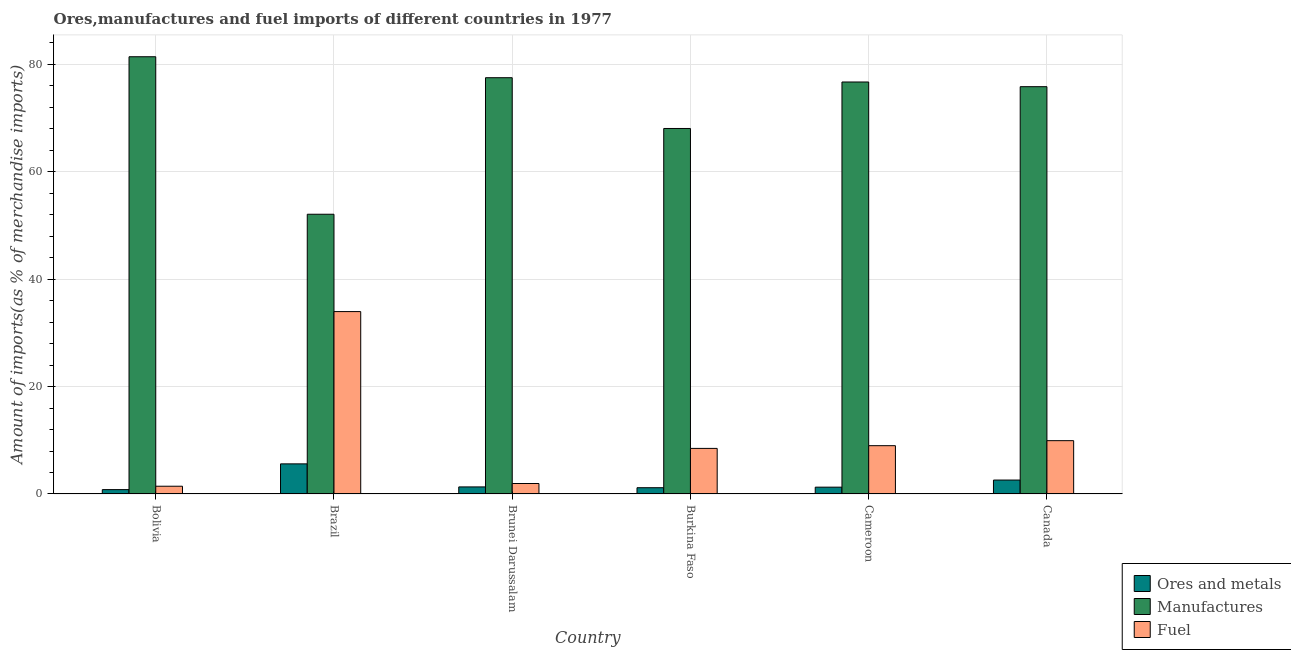Are the number of bars per tick equal to the number of legend labels?
Provide a succinct answer. Yes. Are the number of bars on each tick of the X-axis equal?
Provide a short and direct response. Yes. How many bars are there on the 1st tick from the right?
Offer a very short reply. 3. What is the label of the 3rd group of bars from the left?
Make the answer very short. Brunei Darussalam. In how many cases, is the number of bars for a given country not equal to the number of legend labels?
Offer a terse response. 0. What is the percentage of fuel imports in Canada?
Give a very brief answer. 9.93. Across all countries, what is the maximum percentage of manufactures imports?
Your response must be concise. 81.43. Across all countries, what is the minimum percentage of manufactures imports?
Offer a very short reply. 52.09. In which country was the percentage of manufactures imports maximum?
Ensure brevity in your answer.  Bolivia. In which country was the percentage of manufactures imports minimum?
Offer a terse response. Brazil. What is the total percentage of manufactures imports in the graph?
Keep it short and to the point. 431.69. What is the difference between the percentage of ores and metals imports in Brazil and that in Burkina Faso?
Offer a very short reply. 4.44. What is the difference between the percentage of fuel imports in Bolivia and the percentage of ores and metals imports in Brazil?
Provide a short and direct response. -4.16. What is the average percentage of ores and metals imports per country?
Give a very brief answer. 2.13. What is the difference between the percentage of fuel imports and percentage of ores and metals imports in Cameroon?
Provide a short and direct response. 7.73. In how many countries, is the percentage of manufactures imports greater than 24 %?
Offer a terse response. 6. What is the ratio of the percentage of fuel imports in Bolivia to that in Canada?
Offer a terse response. 0.15. What is the difference between the highest and the second highest percentage of manufactures imports?
Make the answer very short. 3.91. What is the difference between the highest and the lowest percentage of manufactures imports?
Offer a very short reply. 29.33. In how many countries, is the percentage of manufactures imports greater than the average percentage of manufactures imports taken over all countries?
Your response must be concise. 4. Is the sum of the percentage of fuel imports in Brunei Darussalam and Cameroon greater than the maximum percentage of ores and metals imports across all countries?
Your answer should be compact. Yes. What does the 1st bar from the left in Cameroon represents?
Ensure brevity in your answer.  Ores and metals. What does the 1st bar from the right in Cameroon represents?
Keep it short and to the point. Fuel. Are all the bars in the graph horizontal?
Your answer should be compact. No. How many countries are there in the graph?
Offer a terse response. 6. Are the values on the major ticks of Y-axis written in scientific E-notation?
Offer a terse response. No. How many legend labels are there?
Give a very brief answer. 3. How are the legend labels stacked?
Offer a very short reply. Vertical. What is the title of the graph?
Make the answer very short. Ores,manufactures and fuel imports of different countries in 1977. What is the label or title of the X-axis?
Provide a succinct answer. Country. What is the label or title of the Y-axis?
Your answer should be very brief. Amount of imports(as % of merchandise imports). What is the Amount of imports(as % of merchandise imports) of Ores and metals in Bolivia?
Your answer should be very brief. 0.81. What is the Amount of imports(as % of merchandise imports) in Manufactures in Bolivia?
Your answer should be very brief. 81.43. What is the Amount of imports(as % of merchandise imports) in Fuel in Bolivia?
Offer a very short reply. 1.44. What is the Amount of imports(as % of merchandise imports) in Ores and metals in Brazil?
Your answer should be very brief. 5.61. What is the Amount of imports(as % of merchandise imports) in Manufactures in Brazil?
Offer a very short reply. 52.09. What is the Amount of imports(as % of merchandise imports) in Fuel in Brazil?
Your answer should be very brief. 33.97. What is the Amount of imports(as % of merchandise imports) in Ores and metals in Brunei Darussalam?
Your response must be concise. 1.31. What is the Amount of imports(as % of merchandise imports) in Manufactures in Brunei Darussalam?
Your answer should be very brief. 77.52. What is the Amount of imports(as % of merchandise imports) in Fuel in Brunei Darussalam?
Your response must be concise. 1.95. What is the Amount of imports(as % of merchandise imports) of Ores and metals in Burkina Faso?
Your answer should be very brief. 1.16. What is the Amount of imports(as % of merchandise imports) in Manufactures in Burkina Faso?
Your answer should be very brief. 68.07. What is the Amount of imports(as % of merchandise imports) of Fuel in Burkina Faso?
Your response must be concise. 8.49. What is the Amount of imports(as % of merchandise imports) of Ores and metals in Cameroon?
Make the answer very short. 1.27. What is the Amount of imports(as % of merchandise imports) in Manufactures in Cameroon?
Give a very brief answer. 76.72. What is the Amount of imports(as % of merchandise imports) in Fuel in Cameroon?
Ensure brevity in your answer.  8.99. What is the Amount of imports(as % of merchandise imports) of Ores and metals in Canada?
Provide a short and direct response. 2.59. What is the Amount of imports(as % of merchandise imports) in Manufactures in Canada?
Your answer should be very brief. 75.85. What is the Amount of imports(as % of merchandise imports) in Fuel in Canada?
Ensure brevity in your answer.  9.93. Across all countries, what is the maximum Amount of imports(as % of merchandise imports) in Ores and metals?
Provide a short and direct response. 5.61. Across all countries, what is the maximum Amount of imports(as % of merchandise imports) of Manufactures?
Provide a succinct answer. 81.43. Across all countries, what is the maximum Amount of imports(as % of merchandise imports) in Fuel?
Keep it short and to the point. 33.97. Across all countries, what is the minimum Amount of imports(as % of merchandise imports) of Ores and metals?
Offer a very short reply. 0.81. Across all countries, what is the minimum Amount of imports(as % of merchandise imports) in Manufactures?
Provide a succinct answer. 52.09. Across all countries, what is the minimum Amount of imports(as % of merchandise imports) of Fuel?
Offer a terse response. 1.44. What is the total Amount of imports(as % of merchandise imports) of Ores and metals in the graph?
Make the answer very short. 12.75. What is the total Amount of imports(as % of merchandise imports) in Manufactures in the graph?
Make the answer very short. 431.69. What is the total Amount of imports(as % of merchandise imports) in Fuel in the graph?
Provide a short and direct response. 64.77. What is the difference between the Amount of imports(as % of merchandise imports) of Ores and metals in Bolivia and that in Brazil?
Offer a very short reply. -4.79. What is the difference between the Amount of imports(as % of merchandise imports) of Manufactures in Bolivia and that in Brazil?
Your answer should be very brief. 29.33. What is the difference between the Amount of imports(as % of merchandise imports) of Fuel in Bolivia and that in Brazil?
Your response must be concise. -32.52. What is the difference between the Amount of imports(as % of merchandise imports) in Ores and metals in Bolivia and that in Brunei Darussalam?
Make the answer very short. -0.5. What is the difference between the Amount of imports(as % of merchandise imports) of Manufactures in Bolivia and that in Brunei Darussalam?
Provide a succinct answer. 3.91. What is the difference between the Amount of imports(as % of merchandise imports) of Fuel in Bolivia and that in Brunei Darussalam?
Offer a terse response. -0.51. What is the difference between the Amount of imports(as % of merchandise imports) of Ores and metals in Bolivia and that in Burkina Faso?
Your answer should be very brief. -0.35. What is the difference between the Amount of imports(as % of merchandise imports) in Manufactures in Bolivia and that in Burkina Faso?
Your answer should be compact. 13.36. What is the difference between the Amount of imports(as % of merchandise imports) of Fuel in Bolivia and that in Burkina Faso?
Provide a short and direct response. -7.04. What is the difference between the Amount of imports(as % of merchandise imports) in Ores and metals in Bolivia and that in Cameroon?
Make the answer very short. -0.45. What is the difference between the Amount of imports(as % of merchandise imports) in Manufactures in Bolivia and that in Cameroon?
Give a very brief answer. 4.7. What is the difference between the Amount of imports(as % of merchandise imports) of Fuel in Bolivia and that in Cameroon?
Provide a succinct answer. -7.55. What is the difference between the Amount of imports(as % of merchandise imports) of Ores and metals in Bolivia and that in Canada?
Offer a very short reply. -1.78. What is the difference between the Amount of imports(as % of merchandise imports) of Manufactures in Bolivia and that in Canada?
Offer a terse response. 5.58. What is the difference between the Amount of imports(as % of merchandise imports) of Fuel in Bolivia and that in Canada?
Make the answer very short. -8.49. What is the difference between the Amount of imports(as % of merchandise imports) in Ores and metals in Brazil and that in Brunei Darussalam?
Provide a succinct answer. 4.29. What is the difference between the Amount of imports(as % of merchandise imports) of Manufactures in Brazil and that in Brunei Darussalam?
Keep it short and to the point. -25.43. What is the difference between the Amount of imports(as % of merchandise imports) in Fuel in Brazil and that in Brunei Darussalam?
Offer a terse response. 32.02. What is the difference between the Amount of imports(as % of merchandise imports) of Ores and metals in Brazil and that in Burkina Faso?
Keep it short and to the point. 4.44. What is the difference between the Amount of imports(as % of merchandise imports) in Manufactures in Brazil and that in Burkina Faso?
Ensure brevity in your answer.  -15.97. What is the difference between the Amount of imports(as % of merchandise imports) in Fuel in Brazil and that in Burkina Faso?
Offer a very short reply. 25.48. What is the difference between the Amount of imports(as % of merchandise imports) of Ores and metals in Brazil and that in Cameroon?
Give a very brief answer. 4.34. What is the difference between the Amount of imports(as % of merchandise imports) in Manufactures in Brazil and that in Cameroon?
Your answer should be compact. -24.63. What is the difference between the Amount of imports(as % of merchandise imports) of Fuel in Brazil and that in Cameroon?
Your answer should be very brief. 24.97. What is the difference between the Amount of imports(as % of merchandise imports) in Ores and metals in Brazil and that in Canada?
Offer a very short reply. 3.01. What is the difference between the Amount of imports(as % of merchandise imports) in Manufactures in Brazil and that in Canada?
Provide a short and direct response. -23.76. What is the difference between the Amount of imports(as % of merchandise imports) in Fuel in Brazil and that in Canada?
Provide a succinct answer. 24.04. What is the difference between the Amount of imports(as % of merchandise imports) in Ores and metals in Brunei Darussalam and that in Burkina Faso?
Keep it short and to the point. 0.15. What is the difference between the Amount of imports(as % of merchandise imports) of Manufactures in Brunei Darussalam and that in Burkina Faso?
Offer a very short reply. 9.45. What is the difference between the Amount of imports(as % of merchandise imports) of Fuel in Brunei Darussalam and that in Burkina Faso?
Make the answer very short. -6.54. What is the difference between the Amount of imports(as % of merchandise imports) of Ores and metals in Brunei Darussalam and that in Cameroon?
Ensure brevity in your answer.  0.05. What is the difference between the Amount of imports(as % of merchandise imports) of Manufactures in Brunei Darussalam and that in Cameroon?
Offer a terse response. 0.8. What is the difference between the Amount of imports(as % of merchandise imports) of Fuel in Brunei Darussalam and that in Cameroon?
Your answer should be compact. -7.04. What is the difference between the Amount of imports(as % of merchandise imports) of Ores and metals in Brunei Darussalam and that in Canada?
Give a very brief answer. -1.28. What is the difference between the Amount of imports(as % of merchandise imports) in Manufactures in Brunei Darussalam and that in Canada?
Offer a very short reply. 1.67. What is the difference between the Amount of imports(as % of merchandise imports) of Fuel in Brunei Darussalam and that in Canada?
Offer a very short reply. -7.98. What is the difference between the Amount of imports(as % of merchandise imports) of Ores and metals in Burkina Faso and that in Cameroon?
Your response must be concise. -0.1. What is the difference between the Amount of imports(as % of merchandise imports) in Manufactures in Burkina Faso and that in Cameroon?
Your answer should be compact. -8.66. What is the difference between the Amount of imports(as % of merchandise imports) in Fuel in Burkina Faso and that in Cameroon?
Give a very brief answer. -0.51. What is the difference between the Amount of imports(as % of merchandise imports) of Ores and metals in Burkina Faso and that in Canada?
Your answer should be very brief. -1.43. What is the difference between the Amount of imports(as % of merchandise imports) in Manufactures in Burkina Faso and that in Canada?
Ensure brevity in your answer.  -7.78. What is the difference between the Amount of imports(as % of merchandise imports) in Fuel in Burkina Faso and that in Canada?
Make the answer very short. -1.44. What is the difference between the Amount of imports(as % of merchandise imports) of Ores and metals in Cameroon and that in Canada?
Ensure brevity in your answer.  -1.32. What is the difference between the Amount of imports(as % of merchandise imports) in Manufactures in Cameroon and that in Canada?
Your response must be concise. 0.87. What is the difference between the Amount of imports(as % of merchandise imports) of Fuel in Cameroon and that in Canada?
Your response must be concise. -0.94. What is the difference between the Amount of imports(as % of merchandise imports) in Ores and metals in Bolivia and the Amount of imports(as % of merchandise imports) in Manufactures in Brazil?
Keep it short and to the point. -51.28. What is the difference between the Amount of imports(as % of merchandise imports) in Ores and metals in Bolivia and the Amount of imports(as % of merchandise imports) in Fuel in Brazil?
Your answer should be very brief. -33.15. What is the difference between the Amount of imports(as % of merchandise imports) in Manufactures in Bolivia and the Amount of imports(as % of merchandise imports) in Fuel in Brazil?
Offer a very short reply. 47.46. What is the difference between the Amount of imports(as % of merchandise imports) in Ores and metals in Bolivia and the Amount of imports(as % of merchandise imports) in Manufactures in Brunei Darussalam?
Give a very brief answer. -76.71. What is the difference between the Amount of imports(as % of merchandise imports) in Ores and metals in Bolivia and the Amount of imports(as % of merchandise imports) in Fuel in Brunei Darussalam?
Your response must be concise. -1.14. What is the difference between the Amount of imports(as % of merchandise imports) in Manufactures in Bolivia and the Amount of imports(as % of merchandise imports) in Fuel in Brunei Darussalam?
Provide a short and direct response. 79.48. What is the difference between the Amount of imports(as % of merchandise imports) in Ores and metals in Bolivia and the Amount of imports(as % of merchandise imports) in Manufactures in Burkina Faso?
Keep it short and to the point. -67.26. What is the difference between the Amount of imports(as % of merchandise imports) in Ores and metals in Bolivia and the Amount of imports(as % of merchandise imports) in Fuel in Burkina Faso?
Your response must be concise. -7.67. What is the difference between the Amount of imports(as % of merchandise imports) in Manufactures in Bolivia and the Amount of imports(as % of merchandise imports) in Fuel in Burkina Faso?
Provide a succinct answer. 72.94. What is the difference between the Amount of imports(as % of merchandise imports) in Ores and metals in Bolivia and the Amount of imports(as % of merchandise imports) in Manufactures in Cameroon?
Keep it short and to the point. -75.91. What is the difference between the Amount of imports(as % of merchandise imports) of Ores and metals in Bolivia and the Amount of imports(as % of merchandise imports) of Fuel in Cameroon?
Provide a succinct answer. -8.18. What is the difference between the Amount of imports(as % of merchandise imports) of Manufactures in Bolivia and the Amount of imports(as % of merchandise imports) of Fuel in Cameroon?
Your answer should be very brief. 72.44. What is the difference between the Amount of imports(as % of merchandise imports) of Ores and metals in Bolivia and the Amount of imports(as % of merchandise imports) of Manufactures in Canada?
Keep it short and to the point. -75.04. What is the difference between the Amount of imports(as % of merchandise imports) of Ores and metals in Bolivia and the Amount of imports(as % of merchandise imports) of Fuel in Canada?
Give a very brief answer. -9.12. What is the difference between the Amount of imports(as % of merchandise imports) of Manufactures in Bolivia and the Amount of imports(as % of merchandise imports) of Fuel in Canada?
Offer a terse response. 71.5. What is the difference between the Amount of imports(as % of merchandise imports) in Ores and metals in Brazil and the Amount of imports(as % of merchandise imports) in Manufactures in Brunei Darussalam?
Your response must be concise. -71.92. What is the difference between the Amount of imports(as % of merchandise imports) of Ores and metals in Brazil and the Amount of imports(as % of merchandise imports) of Fuel in Brunei Darussalam?
Provide a short and direct response. 3.66. What is the difference between the Amount of imports(as % of merchandise imports) of Manufactures in Brazil and the Amount of imports(as % of merchandise imports) of Fuel in Brunei Darussalam?
Your answer should be very brief. 50.15. What is the difference between the Amount of imports(as % of merchandise imports) in Ores and metals in Brazil and the Amount of imports(as % of merchandise imports) in Manufactures in Burkina Faso?
Your response must be concise. -62.46. What is the difference between the Amount of imports(as % of merchandise imports) in Ores and metals in Brazil and the Amount of imports(as % of merchandise imports) in Fuel in Burkina Faso?
Offer a very short reply. -2.88. What is the difference between the Amount of imports(as % of merchandise imports) of Manufactures in Brazil and the Amount of imports(as % of merchandise imports) of Fuel in Burkina Faso?
Your answer should be compact. 43.61. What is the difference between the Amount of imports(as % of merchandise imports) of Ores and metals in Brazil and the Amount of imports(as % of merchandise imports) of Manufactures in Cameroon?
Give a very brief answer. -71.12. What is the difference between the Amount of imports(as % of merchandise imports) of Ores and metals in Brazil and the Amount of imports(as % of merchandise imports) of Fuel in Cameroon?
Ensure brevity in your answer.  -3.39. What is the difference between the Amount of imports(as % of merchandise imports) in Manufactures in Brazil and the Amount of imports(as % of merchandise imports) in Fuel in Cameroon?
Provide a succinct answer. 43.1. What is the difference between the Amount of imports(as % of merchandise imports) of Ores and metals in Brazil and the Amount of imports(as % of merchandise imports) of Manufactures in Canada?
Offer a very short reply. -70.25. What is the difference between the Amount of imports(as % of merchandise imports) of Ores and metals in Brazil and the Amount of imports(as % of merchandise imports) of Fuel in Canada?
Provide a short and direct response. -4.32. What is the difference between the Amount of imports(as % of merchandise imports) of Manufactures in Brazil and the Amount of imports(as % of merchandise imports) of Fuel in Canada?
Offer a terse response. 42.17. What is the difference between the Amount of imports(as % of merchandise imports) of Ores and metals in Brunei Darussalam and the Amount of imports(as % of merchandise imports) of Manufactures in Burkina Faso?
Give a very brief answer. -66.75. What is the difference between the Amount of imports(as % of merchandise imports) of Ores and metals in Brunei Darussalam and the Amount of imports(as % of merchandise imports) of Fuel in Burkina Faso?
Give a very brief answer. -7.17. What is the difference between the Amount of imports(as % of merchandise imports) in Manufactures in Brunei Darussalam and the Amount of imports(as % of merchandise imports) in Fuel in Burkina Faso?
Make the answer very short. 69.04. What is the difference between the Amount of imports(as % of merchandise imports) in Ores and metals in Brunei Darussalam and the Amount of imports(as % of merchandise imports) in Manufactures in Cameroon?
Offer a very short reply. -75.41. What is the difference between the Amount of imports(as % of merchandise imports) in Ores and metals in Brunei Darussalam and the Amount of imports(as % of merchandise imports) in Fuel in Cameroon?
Ensure brevity in your answer.  -7.68. What is the difference between the Amount of imports(as % of merchandise imports) in Manufactures in Brunei Darussalam and the Amount of imports(as % of merchandise imports) in Fuel in Cameroon?
Provide a short and direct response. 68.53. What is the difference between the Amount of imports(as % of merchandise imports) in Ores and metals in Brunei Darussalam and the Amount of imports(as % of merchandise imports) in Manufactures in Canada?
Your answer should be very brief. -74.54. What is the difference between the Amount of imports(as % of merchandise imports) in Ores and metals in Brunei Darussalam and the Amount of imports(as % of merchandise imports) in Fuel in Canada?
Offer a very short reply. -8.61. What is the difference between the Amount of imports(as % of merchandise imports) of Manufactures in Brunei Darussalam and the Amount of imports(as % of merchandise imports) of Fuel in Canada?
Make the answer very short. 67.59. What is the difference between the Amount of imports(as % of merchandise imports) of Ores and metals in Burkina Faso and the Amount of imports(as % of merchandise imports) of Manufactures in Cameroon?
Provide a short and direct response. -75.56. What is the difference between the Amount of imports(as % of merchandise imports) in Ores and metals in Burkina Faso and the Amount of imports(as % of merchandise imports) in Fuel in Cameroon?
Make the answer very short. -7.83. What is the difference between the Amount of imports(as % of merchandise imports) in Manufactures in Burkina Faso and the Amount of imports(as % of merchandise imports) in Fuel in Cameroon?
Provide a succinct answer. 59.07. What is the difference between the Amount of imports(as % of merchandise imports) of Ores and metals in Burkina Faso and the Amount of imports(as % of merchandise imports) of Manufactures in Canada?
Provide a short and direct response. -74.69. What is the difference between the Amount of imports(as % of merchandise imports) of Ores and metals in Burkina Faso and the Amount of imports(as % of merchandise imports) of Fuel in Canada?
Offer a very short reply. -8.76. What is the difference between the Amount of imports(as % of merchandise imports) of Manufactures in Burkina Faso and the Amount of imports(as % of merchandise imports) of Fuel in Canada?
Offer a terse response. 58.14. What is the difference between the Amount of imports(as % of merchandise imports) of Ores and metals in Cameroon and the Amount of imports(as % of merchandise imports) of Manufactures in Canada?
Keep it short and to the point. -74.58. What is the difference between the Amount of imports(as % of merchandise imports) in Ores and metals in Cameroon and the Amount of imports(as % of merchandise imports) in Fuel in Canada?
Ensure brevity in your answer.  -8.66. What is the difference between the Amount of imports(as % of merchandise imports) in Manufactures in Cameroon and the Amount of imports(as % of merchandise imports) in Fuel in Canada?
Provide a short and direct response. 66.8. What is the average Amount of imports(as % of merchandise imports) of Ores and metals per country?
Provide a short and direct response. 2.13. What is the average Amount of imports(as % of merchandise imports) in Manufactures per country?
Your answer should be very brief. 71.95. What is the average Amount of imports(as % of merchandise imports) of Fuel per country?
Offer a very short reply. 10.79. What is the difference between the Amount of imports(as % of merchandise imports) in Ores and metals and Amount of imports(as % of merchandise imports) in Manufactures in Bolivia?
Your answer should be compact. -80.62. What is the difference between the Amount of imports(as % of merchandise imports) of Ores and metals and Amount of imports(as % of merchandise imports) of Fuel in Bolivia?
Offer a terse response. -0.63. What is the difference between the Amount of imports(as % of merchandise imports) of Manufactures and Amount of imports(as % of merchandise imports) of Fuel in Bolivia?
Offer a terse response. 79.99. What is the difference between the Amount of imports(as % of merchandise imports) in Ores and metals and Amount of imports(as % of merchandise imports) in Manufactures in Brazil?
Your answer should be very brief. -46.49. What is the difference between the Amount of imports(as % of merchandise imports) of Ores and metals and Amount of imports(as % of merchandise imports) of Fuel in Brazil?
Provide a short and direct response. -28.36. What is the difference between the Amount of imports(as % of merchandise imports) in Manufactures and Amount of imports(as % of merchandise imports) in Fuel in Brazil?
Your response must be concise. 18.13. What is the difference between the Amount of imports(as % of merchandise imports) of Ores and metals and Amount of imports(as % of merchandise imports) of Manufactures in Brunei Darussalam?
Give a very brief answer. -76.21. What is the difference between the Amount of imports(as % of merchandise imports) of Ores and metals and Amount of imports(as % of merchandise imports) of Fuel in Brunei Darussalam?
Offer a terse response. -0.63. What is the difference between the Amount of imports(as % of merchandise imports) of Manufactures and Amount of imports(as % of merchandise imports) of Fuel in Brunei Darussalam?
Offer a very short reply. 75.57. What is the difference between the Amount of imports(as % of merchandise imports) in Ores and metals and Amount of imports(as % of merchandise imports) in Manufactures in Burkina Faso?
Offer a terse response. -66.9. What is the difference between the Amount of imports(as % of merchandise imports) of Ores and metals and Amount of imports(as % of merchandise imports) of Fuel in Burkina Faso?
Your answer should be compact. -7.32. What is the difference between the Amount of imports(as % of merchandise imports) in Manufactures and Amount of imports(as % of merchandise imports) in Fuel in Burkina Faso?
Provide a succinct answer. 59.58. What is the difference between the Amount of imports(as % of merchandise imports) of Ores and metals and Amount of imports(as % of merchandise imports) of Manufactures in Cameroon?
Provide a succinct answer. -75.46. What is the difference between the Amount of imports(as % of merchandise imports) in Ores and metals and Amount of imports(as % of merchandise imports) in Fuel in Cameroon?
Your answer should be very brief. -7.73. What is the difference between the Amount of imports(as % of merchandise imports) in Manufactures and Amount of imports(as % of merchandise imports) in Fuel in Cameroon?
Provide a succinct answer. 67.73. What is the difference between the Amount of imports(as % of merchandise imports) in Ores and metals and Amount of imports(as % of merchandise imports) in Manufactures in Canada?
Your answer should be very brief. -73.26. What is the difference between the Amount of imports(as % of merchandise imports) in Ores and metals and Amount of imports(as % of merchandise imports) in Fuel in Canada?
Your response must be concise. -7.34. What is the difference between the Amount of imports(as % of merchandise imports) of Manufactures and Amount of imports(as % of merchandise imports) of Fuel in Canada?
Keep it short and to the point. 65.92. What is the ratio of the Amount of imports(as % of merchandise imports) of Ores and metals in Bolivia to that in Brazil?
Ensure brevity in your answer.  0.14. What is the ratio of the Amount of imports(as % of merchandise imports) of Manufactures in Bolivia to that in Brazil?
Make the answer very short. 1.56. What is the ratio of the Amount of imports(as % of merchandise imports) in Fuel in Bolivia to that in Brazil?
Your response must be concise. 0.04. What is the ratio of the Amount of imports(as % of merchandise imports) in Ores and metals in Bolivia to that in Brunei Darussalam?
Your answer should be compact. 0.62. What is the ratio of the Amount of imports(as % of merchandise imports) of Manufactures in Bolivia to that in Brunei Darussalam?
Ensure brevity in your answer.  1.05. What is the ratio of the Amount of imports(as % of merchandise imports) of Fuel in Bolivia to that in Brunei Darussalam?
Offer a very short reply. 0.74. What is the ratio of the Amount of imports(as % of merchandise imports) of Ores and metals in Bolivia to that in Burkina Faso?
Make the answer very short. 0.7. What is the ratio of the Amount of imports(as % of merchandise imports) of Manufactures in Bolivia to that in Burkina Faso?
Give a very brief answer. 1.2. What is the ratio of the Amount of imports(as % of merchandise imports) of Fuel in Bolivia to that in Burkina Faso?
Give a very brief answer. 0.17. What is the ratio of the Amount of imports(as % of merchandise imports) in Ores and metals in Bolivia to that in Cameroon?
Give a very brief answer. 0.64. What is the ratio of the Amount of imports(as % of merchandise imports) in Manufactures in Bolivia to that in Cameroon?
Your answer should be compact. 1.06. What is the ratio of the Amount of imports(as % of merchandise imports) of Fuel in Bolivia to that in Cameroon?
Your answer should be very brief. 0.16. What is the ratio of the Amount of imports(as % of merchandise imports) of Ores and metals in Bolivia to that in Canada?
Your answer should be very brief. 0.31. What is the ratio of the Amount of imports(as % of merchandise imports) of Manufactures in Bolivia to that in Canada?
Keep it short and to the point. 1.07. What is the ratio of the Amount of imports(as % of merchandise imports) in Fuel in Bolivia to that in Canada?
Make the answer very short. 0.15. What is the ratio of the Amount of imports(as % of merchandise imports) of Ores and metals in Brazil to that in Brunei Darussalam?
Keep it short and to the point. 4.26. What is the ratio of the Amount of imports(as % of merchandise imports) in Manufactures in Brazil to that in Brunei Darussalam?
Ensure brevity in your answer.  0.67. What is the ratio of the Amount of imports(as % of merchandise imports) of Fuel in Brazil to that in Brunei Darussalam?
Give a very brief answer. 17.42. What is the ratio of the Amount of imports(as % of merchandise imports) in Ores and metals in Brazil to that in Burkina Faso?
Ensure brevity in your answer.  4.81. What is the ratio of the Amount of imports(as % of merchandise imports) in Manufactures in Brazil to that in Burkina Faso?
Make the answer very short. 0.77. What is the ratio of the Amount of imports(as % of merchandise imports) in Fuel in Brazil to that in Burkina Faso?
Your answer should be very brief. 4. What is the ratio of the Amount of imports(as % of merchandise imports) of Ores and metals in Brazil to that in Cameroon?
Ensure brevity in your answer.  4.43. What is the ratio of the Amount of imports(as % of merchandise imports) in Manufactures in Brazil to that in Cameroon?
Your answer should be compact. 0.68. What is the ratio of the Amount of imports(as % of merchandise imports) of Fuel in Brazil to that in Cameroon?
Make the answer very short. 3.78. What is the ratio of the Amount of imports(as % of merchandise imports) of Ores and metals in Brazil to that in Canada?
Offer a very short reply. 2.16. What is the ratio of the Amount of imports(as % of merchandise imports) of Manufactures in Brazil to that in Canada?
Your response must be concise. 0.69. What is the ratio of the Amount of imports(as % of merchandise imports) of Fuel in Brazil to that in Canada?
Keep it short and to the point. 3.42. What is the ratio of the Amount of imports(as % of merchandise imports) in Ores and metals in Brunei Darussalam to that in Burkina Faso?
Make the answer very short. 1.13. What is the ratio of the Amount of imports(as % of merchandise imports) of Manufactures in Brunei Darussalam to that in Burkina Faso?
Your answer should be very brief. 1.14. What is the ratio of the Amount of imports(as % of merchandise imports) of Fuel in Brunei Darussalam to that in Burkina Faso?
Offer a terse response. 0.23. What is the ratio of the Amount of imports(as % of merchandise imports) in Ores and metals in Brunei Darussalam to that in Cameroon?
Provide a succinct answer. 1.04. What is the ratio of the Amount of imports(as % of merchandise imports) of Manufactures in Brunei Darussalam to that in Cameroon?
Your response must be concise. 1.01. What is the ratio of the Amount of imports(as % of merchandise imports) in Fuel in Brunei Darussalam to that in Cameroon?
Provide a succinct answer. 0.22. What is the ratio of the Amount of imports(as % of merchandise imports) in Ores and metals in Brunei Darussalam to that in Canada?
Provide a succinct answer. 0.51. What is the ratio of the Amount of imports(as % of merchandise imports) of Manufactures in Brunei Darussalam to that in Canada?
Offer a very short reply. 1.02. What is the ratio of the Amount of imports(as % of merchandise imports) of Fuel in Brunei Darussalam to that in Canada?
Ensure brevity in your answer.  0.2. What is the ratio of the Amount of imports(as % of merchandise imports) in Ores and metals in Burkina Faso to that in Cameroon?
Provide a succinct answer. 0.92. What is the ratio of the Amount of imports(as % of merchandise imports) in Manufactures in Burkina Faso to that in Cameroon?
Give a very brief answer. 0.89. What is the ratio of the Amount of imports(as % of merchandise imports) in Fuel in Burkina Faso to that in Cameroon?
Keep it short and to the point. 0.94. What is the ratio of the Amount of imports(as % of merchandise imports) of Ores and metals in Burkina Faso to that in Canada?
Your response must be concise. 0.45. What is the ratio of the Amount of imports(as % of merchandise imports) in Manufactures in Burkina Faso to that in Canada?
Offer a very short reply. 0.9. What is the ratio of the Amount of imports(as % of merchandise imports) of Fuel in Burkina Faso to that in Canada?
Your answer should be compact. 0.85. What is the ratio of the Amount of imports(as % of merchandise imports) in Ores and metals in Cameroon to that in Canada?
Give a very brief answer. 0.49. What is the ratio of the Amount of imports(as % of merchandise imports) in Manufactures in Cameroon to that in Canada?
Offer a terse response. 1.01. What is the ratio of the Amount of imports(as % of merchandise imports) in Fuel in Cameroon to that in Canada?
Ensure brevity in your answer.  0.91. What is the difference between the highest and the second highest Amount of imports(as % of merchandise imports) in Ores and metals?
Ensure brevity in your answer.  3.01. What is the difference between the highest and the second highest Amount of imports(as % of merchandise imports) of Manufactures?
Give a very brief answer. 3.91. What is the difference between the highest and the second highest Amount of imports(as % of merchandise imports) in Fuel?
Give a very brief answer. 24.04. What is the difference between the highest and the lowest Amount of imports(as % of merchandise imports) in Ores and metals?
Your answer should be compact. 4.79. What is the difference between the highest and the lowest Amount of imports(as % of merchandise imports) of Manufactures?
Your response must be concise. 29.33. What is the difference between the highest and the lowest Amount of imports(as % of merchandise imports) in Fuel?
Your response must be concise. 32.52. 